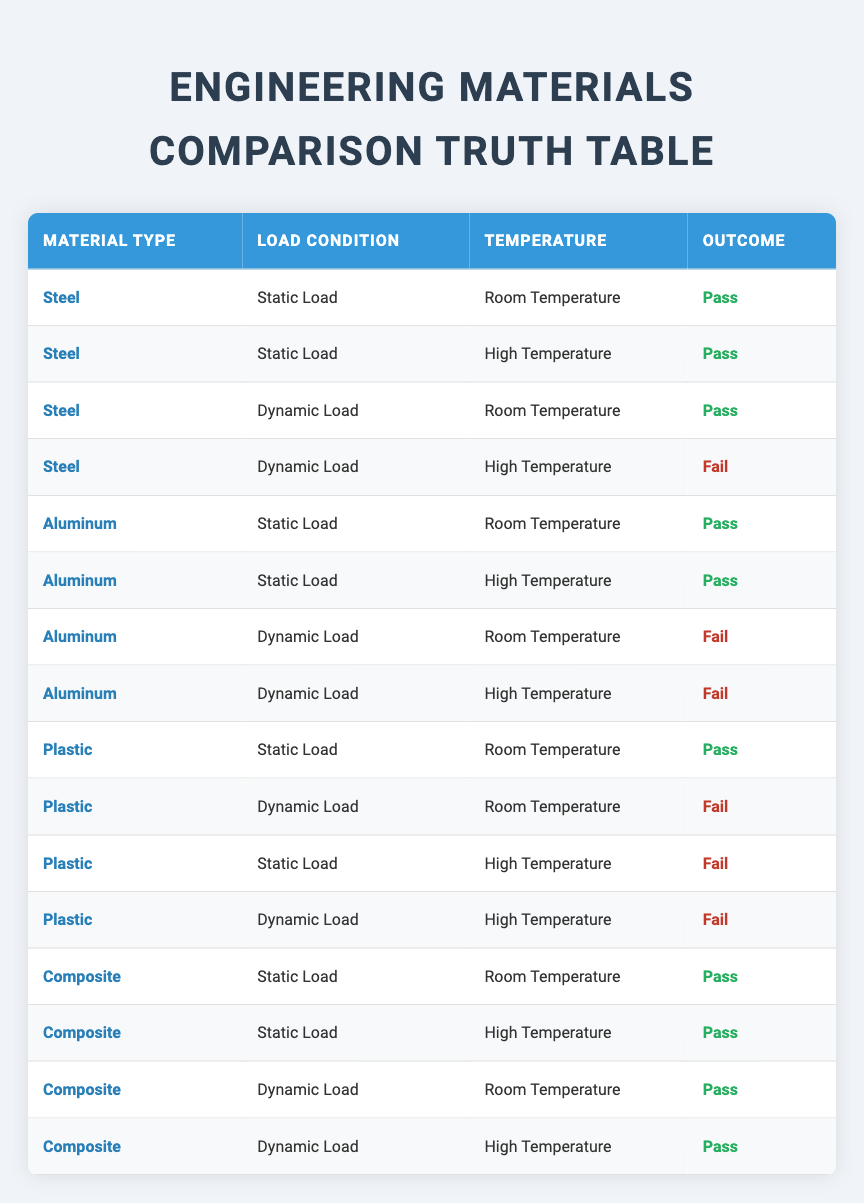What is the outcome when using Steel under Dynamic Load at High Temperature? In the table, the row corresponding to Steel under Dynamic Load at High Temperature shows an outcome of "Fail."
Answer: Fail How many materials pass under Static Load at Room Temperature? In the table, both Steel, Aluminum, and Plastic have an outcome of "Pass" when subjected to Static Load at Room Temperature. Therefore, there are a total of 3 materials that pass.
Answer: 3 Do Aluminum materials fail under Dynamic Load at Low Temperature? The table does not list any trials for Aluminum under Dynamic Load at Low Temperature. Therefore, we cannot determine if it would pass or fail in that condition. The answer is "No."
Answer: No Which material has the highest number of "Pass" outcomes across all load conditions and temperature settings? By examining the table, we can count the outcomes: Steel has 3 Passes, Aluminum has 2 Passes, Plastic has 1 Pass, and Composite has 4 Passes. Composite has the highest number of Pass outcomes.
Answer: Composite Is there a condition where Plastic materials pass? The table indicates that Plastic materials pass only under Static Load at Room Temperature. All other conditions for Plastic result in a failure, thus confirming the existence of passing conditions. Answering this gives us a "Yes."
Answer: Yes What is the total number of "Fail" outcomes for the Aluminum material? In the table, Aluminum has 2 Fail outcomes listed (Dynamic Load at Room Temperature and High Temperature). Therefore, the total number of Fail outcomes for Aluminum is 2.
Answer: 2 Under which conditions does Composite fail? Looking at the table, Composite does not have any conditions where it fails; all outcomes listed for Composite are "Pass". Thus, the answer is that Composite does not experience a fail.
Answer: None What percentage of total outcomes result in a "Pass"? There are 16 total entries in the truth table, with 10 of them resulting in a "Pass." To find the percentage, we calculate (10/16) * 100 = 62.5%.
Answer: 62.5% How many total conditions were tested for Plastic materials? The table lists four conditions tested for Plastic materials: Static Load at Room Temp, Dynamic Load at Room Temp, Static Load at High Temp, and Dynamic Load at High Temp. Therefore, a total of 4 conditions were tested.
Answer: 4 